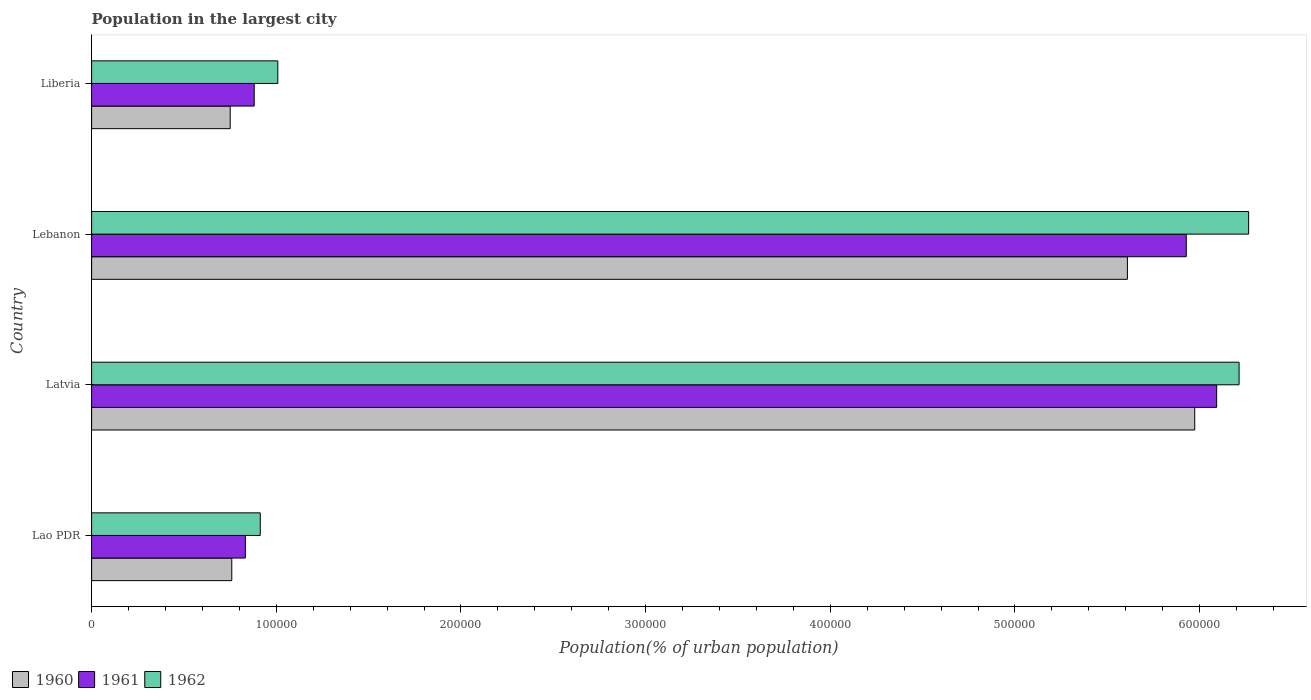How many different coloured bars are there?
Offer a terse response. 3. How many bars are there on the 4th tick from the bottom?
Keep it short and to the point. 3. What is the label of the 1st group of bars from the top?
Ensure brevity in your answer.  Liberia. In how many cases, is the number of bars for a given country not equal to the number of legend labels?
Ensure brevity in your answer.  0. What is the population in the largest city in 1961 in Latvia?
Your answer should be very brief. 6.09e+05. Across all countries, what is the maximum population in the largest city in 1961?
Your answer should be very brief. 6.09e+05. Across all countries, what is the minimum population in the largest city in 1960?
Your response must be concise. 7.51e+04. In which country was the population in the largest city in 1960 maximum?
Offer a very short reply. Latvia. In which country was the population in the largest city in 1961 minimum?
Keep it short and to the point. Lao PDR. What is the total population in the largest city in 1960 in the graph?
Ensure brevity in your answer.  1.31e+06. What is the difference between the population in the largest city in 1961 in Lao PDR and that in Liberia?
Give a very brief answer. -4797. What is the difference between the population in the largest city in 1962 in Lao PDR and the population in the largest city in 1960 in Liberia?
Make the answer very short. 1.63e+04. What is the average population in the largest city in 1962 per country?
Offer a terse response. 3.60e+05. What is the difference between the population in the largest city in 1961 and population in the largest city in 1960 in Lebanon?
Offer a terse response. 3.19e+04. What is the ratio of the population in the largest city in 1961 in Lebanon to that in Liberia?
Provide a short and direct response. 6.73. Is the population in the largest city in 1960 in Lebanon less than that in Liberia?
Make the answer very short. No. What is the difference between the highest and the second highest population in the largest city in 1960?
Offer a terse response. 3.65e+04. What is the difference between the highest and the lowest population in the largest city in 1961?
Ensure brevity in your answer.  5.26e+05. In how many countries, is the population in the largest city in 1960 greater than the average population in the largest city in 1960 taken over all countries?
Provide a short and direct response. 2. Is the sum of the population in the largest city in 1962 in Lao PDR and Latvia greater than the maximum population in the largest city in 1961 across all countries?
Make the answer very short. Yes. Is it the case that in every country, the sum of the population in the largest city in 1961 and population in the largest city in 1962 is greater than the population in the largest city in 1960?
Ensure brevity in your answer.  Yes. How many bars are there?
Make the answer very short. 12. What is the difference between two consecutive major ticks on the X-axis?
Provide a short and direct response. 1.00e+05. Are the values on the major ticks of X-axis written in scientific E-notation?
Your answer should be compact. No. Does the graph contain any zero values?
Offer a terse response. No. Does the graph contain grids?
Make the answer very short. No. Where does the legend appear in the graph?
Provide a succinct answer. Bottom left. How many legend labels are there?
Your answer should be very brief. 3. How are the legend labels stacked?
Your answer should be very brief. Horizontal. What is the title of the graph?
Provide a succinct answer. Population in the largest city. What is the label or title of the X-axis?
Your answer should be compact. Population(% of urban population). What is the label or title of the Y-axis?
Ensure brevity in your answer.  Country. What is the Population(% of urban population) of 1960 in Lao PDR?
Give a very brief answer. 7.59e+04. What is the Population(% of urban population) in 1961 in Lao PDR?
Provide a short and direct response. 8.33e+04. What is the Population(% of urban population) in 1962 in Lao PDR?
Make the answer very short. 9.13e+04. What is the Population(% of urban population) in 1960 in Latvia?
Ensure brevity in your answer.  5.97e+05. What is the Population(% of urban population) of 1961 in Latvia?
Your response must be concise. 6.09e+05. What is the Population(% of urban population) of 1962 in Latvia?
Provide a succinct answer. 6.21e+05. What is the Population(% of urban population) in 1960 in Lebanon?
Keep it short and to the point. 5.61e+05. What is the Population(% of urban population) of 1961 in Lebanon?
Provide a short and direct response. 5.93e+05. What is the Population(% of urban population) of 1962 in Lebanon?
Your answer should be very brief. 6.27e+05. What is the Population(% of urban population) in 1960 in Liberia?
Your answer should be compact. 7.51e+04. What is the Population(% of urban population) of 1961 in Liberia?
Your answer should be very brief. 8.81e+04. What is the Population(% of urban population) of 1962 in Liberia?
Offer a very short reply. 1.01e+05. Across all countries, what is the maximum Population(% of urban population) in 1960?
Provide a succinct answer. 5.97e+05. Across all countries, what is the maximum Population(% of urban population) of 1961?
Your response must be concise. 6.09e+05. Across all countries, what is the maximum Population(% of urban population) in 1962?
Your answer should be compact. 6.27e+05. Across all countries, what is the minimum Population(% of urban population) of 1960?
Your answer should be very brief. 7.51e+04. Across all countries, what is the minimum Population(% of urban population) in 1961?
Give a very brief answer. 8.33e+04. Across all countries, what is the minimum Population(% of urban population) of 1962?
Ensure brevity in your answer.  9.13e+04. What is the total Population(% of urban population) of 1960 in the graph?
Your answer should be compact. 1.31e+06. What is the total Population(% of urban population) in 1961 in the graph?
Your answer should be very brief. 1.37e+06. What is the total Population(% of urban population) in 1962 in the graph?
Keep it short and to the point. 1.44e+06. What is the difference between the Population(% of urban population) in 1960 in Lao PDR and that in Latvia?
Make the answer very short. -5.21e+05. What is the difference between the Population(% of urban population) in 1961 in Lao PDR and that in Latvia?
Your response must be concise. -5.26e+05. What is the difference between the Population(% of urban population) of 1962 in Lao PDR and that in Latvia?
Make the answer very short. -5.30e+05. What is the difference between the Population(% of urban population) of 1960 in Lao PDR and that in Lebanon?
Provide a short and direct response. -4.85e+05. What is the difference between the Population(% of urban population) in 1961 in Lao PDR and that in Lebanon?
Provide a short and direct response. -5.10e+05. What is the difference between the Population(% of urban population) of 1962 in Lao PDR and that in Lebanon?
Keep it short and to the point. -5.35e+05. What is the difference between the Population(% of urban population) in 1960 in Lao PDR and that in Liberia?
Offer a terse response. 851. What is the difference between the Population(% of urban population) in 1961 in Lao PDR and that in Liberia?
Your answer should be compact. -4797. What is the difference between the Population(% of urban population) of 1962 in Lao PDR and that in Liberia?
Offer a very short reply. -9502. What is the difference between the Population(% of urban population) in 1960 in Latvia and that in Lebanon?
Offer a very short reply. 3.65e+04. What is the difference between the Population(% of urban population) of 1961 in Latvia and that in Lebanon?
Offer a very short reply. 1.64e+04. What is the difference between the Population(% of urban population) in 1962 in Latvia and that in Lebanon?
Make the answer very short. -5172. What is the difference between the Population(% of urban population) in 1960 in Latvia and that in Liberia?
Make the answer very short. 5.22e+05. What is the difference between the Population(% of urban population) in 1961 in Latvia and that in Liberia?
Your response must be concise. 5.21e+05. What is the difference between the Population(% of urban population) of 1962 in Latvia and that in Liberia?
Give a very brief answer. 5.21e+05. What is the difference between the Population(% of urban population) of 1960 in Lebanon and that in Liberia?
Offer a terse response. 4.86e+05. What is the difference between the Population(% of urban population) of 1961 in Lebanon and that in Liberia?
Your answer should be compact. 5.05e+05. What is the difference between the Population(% of urban population) of 1962 in Lebanon and that in Liberia?
Make the answer very short. 5.26e+05. What is the difference between the Population(% of urban population) of 1960 in Lao PDR and the Population(% of urban population) of 1961 in Latvia?
Your answer should be very brief. -5.33e+05. What is the difference between the Population(% of urban population) in 1960 in Lao PDR and the Population(% of urban population) in 1962 in Latvia?
Your answer should be very brief. -5.45e+05. What is the difference between the Population(% of urban population) in 1961 in Lao PDR and the Population(% of urban population) in 1962 in Latvia?
Your answer should be very brief. -5.38e+05. What is the difference between the Population(% of urban population) of 1960 in Lao PDR and the Population(% of urban population) of 1961 in Lebanon?
Offer a very short reply. -5.17e+05. What is the difference between the Population(% of urban population) of 1960 in Lao PDR and the Population(% of urban population) of 1962 in Lebanon?
Your answer should be very brief. -5.51e+05. What is the difference between the Population(% of urban population) of 1961 in Lao PDR and the Population(% of urban population) of 1962 in Lebanon?
Provide a short and direct response. -5.43e+05. What is the difference between the Population(% of urban population) of 1960 in Lao PDR and the Population(% of urban population) of 1961 in Liberia?
Give a very brief answer. -1.21e+04. What is the difference between the Population(% of urban population) of 1960 in Lao PDR and the Population(% of urban population) of 1962 in Liberia?
Your response must be concise. -2.49e+04. What is the difference between the Population(% of urban population) in 1961 in Lao PDR and the Population(% of urban population) in 1962 in Liberia?
Make the answer very short. -1.76e+04. What is the difference between the Population(% of urban population) of 1960 in Latvia and the Population(% of urban population) of 1961 in Lebanon?
Provide a short and direct response. 4565. What is the difference between the Population(% of urban population) in 1960 in Latvia and the Population(% of urban population) in 1962 in Lebanon?
Ensure brevity in your answer.  -2.92e+04. What is the difference between the Population(% of urban population) in 1961 in Latvia and the Population(% of urban population) in 1962 in Lebanon?
Your response must be concise. -1.73e+04. What is the difference between the Population(% of urban population) of 1960 in Latvia and the Population(% of urban population) of 1961 in Liberia?
Your answer should be compact. 5.09e+05. What is the difference between the Population(% of urban population) of 1960 in Latvia and the Population(% of urban population) of 1962 in Liberia?
Ensure brevity in your answer.  4.97e+05. What is the difference between the Population(% of urban population) in 1961 in Latvia and the Population(% of urban population) in 1962 in Liberia?
Ensure brevity in your answer.  5.08e+05. What is the difference between the Population(% of urban population) in 1960 in Lebanon and the Population(% of urban population) in 1961 in Liberia?
Offer a very short reply. 4.73e+05. What is the difference between the Population(% of urban population) in 1960 in Lebanon and the Population(% of urban population) in 1962 in Liberia?
Your response must be concise. 4.60e+05. What is the difference between the Population(% of urban population) of 1961 in Lebanon and the Population(% of urban population) of 1962 in Liberia?
Your answer should be very brief. 4.92e+05. What is the average Population(% of urban population) in 1960 per country?
Give a very brief answer. 3.27e+05. What is the average Population(% of urban population) of 1961 per country?
Offer a terse response. 3.43e+05. What is the average Population(% of urban population) of 1962 per country?
Keep it short and to the point. 3.60e+05. What is the difference between the Population(% of urban population) in 1960 and Population(% of urban population) in 1961 in Lao PDR?
Offer a very short reply. -7350. What is the difference between the Population(% of urban population) of 1960 and Population(% of urban population) of 1962 in Lao PDR?
Offer a terse response. -1.54e+04. What is the difference between the Population(% of urban population) of 1961 and Population(% of urban population) of 1962 in Lao PDR?
Your answer should be compact. -8074. What is the difference between the Population(% of urban population) in 1960 and Population(% of urban population) in 1961 in Latvia?
Your answer should be very brief. -1.19e+04. What is the difference between the Population(% of urban population) of 1960 and Population(% of urban population) of 1962 in Latvia?
Your answer should be compact. -2.40e+04. What is the difference between the Population(% of urban population) in 1961 and Population(% of urban population) in 1962 in Latvia?
Offer a terse response. -1.21e+04. What is the difference between the Population(% of urban population) in 1960 and Population(% of urban population) in 1961 in Lebanon?
Give a very brief answer. -3.19e+04. What is the difference between the Population(% of urban population) in 1960 and Population(% of urban population) in 1962 in Lebanon?
Ensure brevity in your answer.  -6.56e+04. What is the difference between the Population(% of urban population) in 1961 and Population(% of urban population) in 1962 in Lebanon?
Keep it short and to the point. -3.38e+04. What is the difference between the Population(% of urban population) in 1960 and Population(% of urban population) in 1961 in Liberia?
Keep it short and to the point. -1.30e+04. What is the difference between the Population(% of urban population) of 1960 and Population(% of urban population) of 1962 in Liberia?
Keep it short and to the point. -2.58e+04. What is the difference between the Population(% of urban population) in 1961 and Population(% of urban population) in 1962 in Liberia?
Ensure brevity in your answer.  -1.28e+04. What is the ratio of the Population(% of urban population) in 1960 in Lao PDR to that in Latvia?
Offer a very short reply. 0.13. What is the ratio of the Population(% of urban population) of 1961 in Lao PDR to that in Latvia?
Make the answer very short. 0.14. What is the ratio of the Population(% of urban population) of 1962 in Lao PDR to that in Latvia?
Provide a succinct answer. 0.15. What is the ratio of the Population(% of urban population) of 1960 in Lao PDR to that in Lebanon?
Keep it short and to the point. 0.14. What is the ratio of the Population(% of urban population) in 1961 in Lao PDR to that in Lebanon?
Offer a very short reply. 0.14. What is the ratio of the Population(% of urban population) of 1962 in Lao PDR to that in Lebanon?
Ensure brevity in your answer.  0.15. What is the ratio of the Population(% of urban population) in 1960 in Lao PDR to that in Liberia?
Provide a succinct answer. 1.01. What is the ratio of the Population(% of urban population) of 1961 in Lao PDR to that in Liberia?
Give a very brief answer. 0.95. What is the ratio of the Population(% of urban population) of 1962 in Lao PDR to that in Liberia?
Ensure brevity in your answer.  0.91. What is the ratio of the Population(% of urban population) in 1960 in Latvia to that in Lebanon?
Keep it short and to the point. 1.06. What is the ratio of the Population(% of urban population) of 1961 in Latvia to that in Lebanon?
Give a very brief answer. 1.03. What is the ratio of the Population(% of urban population) in 1962 in Latvia to that in Lebanon?
Your answer should be very brief. 0.99. What is the ratio of the Population(% of urban population) of 1960 in Latvia to that in Liberia?
Provide a short and direct response. 7.96. What is the ratio of the Population(% of urban population) of 1961 in Latvia to that in Liberia?
Provide a succinct answer. 6.92. What is the ratio of the Population(% of urban population) of 1962 in Latvia to that in Liberia?
Offer a terse response. 6.16. What is the ratio of the Population(% of urban population) in 1960 in Lebanon to that in Liberia?
Give a very brief answer. 7.47. What is the ratio of the Population(% of urban population) in 1961 in Lebanon to that in Liberia?
Your response must be concise. 6.73. What is the ratio of the Population(% of urban population) in 1962 in Lebanon to that in Liberia?
Provide a short and direct response. 6.21. What is the difference between the highest and the second highest Population(% of urban population) of 1960?
Provide a short and direct response. 3.65e+04. What is the difference between the highest and the second highest Population(% of urban population) of 1961?
Provide a succinct answer. 1.64e+04. What is the difference between the highest and the second highest Population(% of urban population) in 1962?
Ensure brevity in your answer.  5172. What is the difference between the highest and the lowest Population(% of urban population) in 1960?
Provide a short and direct response. 5.22e+05. What is the difference between the highest and the lowest Population(% of urban population) of 1961?
Keep it short and to the point. 5.26e+05. What is the difference between the highest and the lowest Population(% of urban population) of 1962?
Keep it short and to the point. 5.35e+05. 